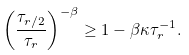Convert formula to latex. <formula><loc_0><loc_0><loc_500><loc_500>\left ( \frac { \tau _ { r / 2 } } { \tau _ { r } } \right ) ^ { - \beta } \geq 1 - \beta \kappa \tau _ { r } ^ { - 1 } .</formula> 